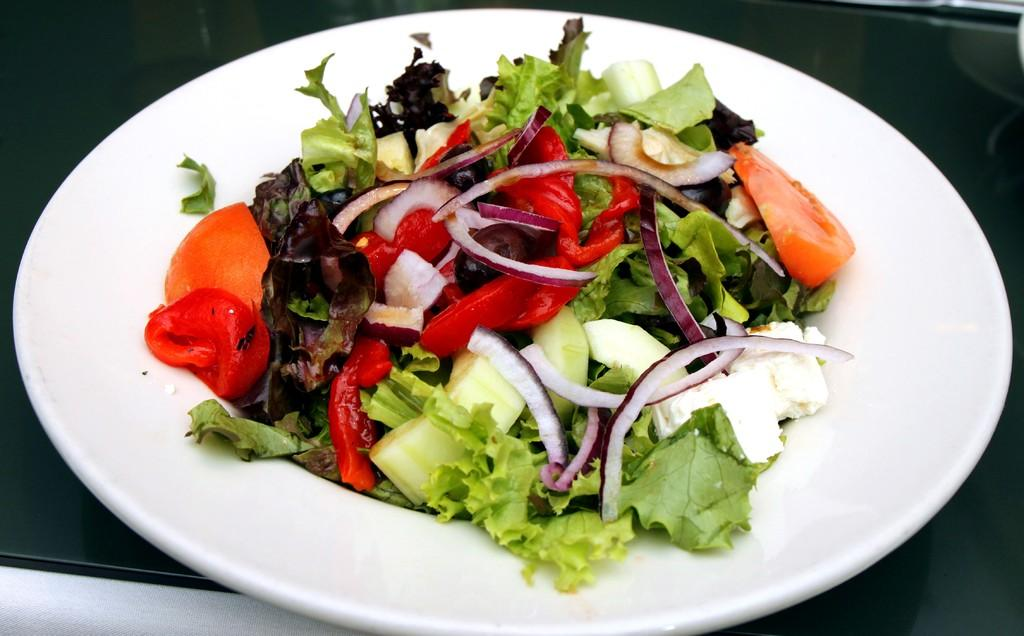What is on the plate that is visible in the image? There are food items on a plate in the image. What is the color of the plate? The plate is white in color. What is the color of the surface the plate is on? The plate is on a black surface. How does the hen use force to skate on the black surface in the image? There is no hen or skating activity present in the image. 